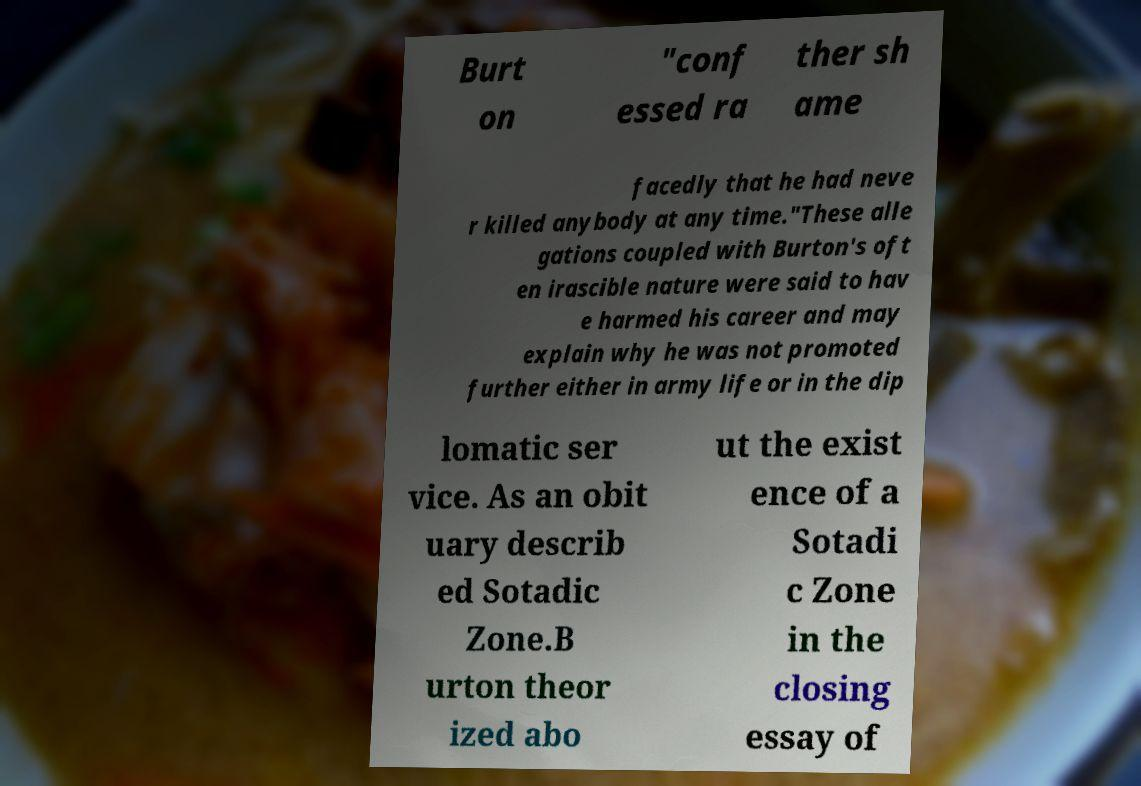There's text embedded in this image that I need extracted. Can you transcribe it verbatim? Burt on "conf essed ra ther sh ame facedly that he had neve r killed anybody at any time."These alle gations coupled with Burton's oft en irascible nature were said to hav e harmed his career and may explain why he was not promoted further either in army life or in the dip lomatic ser vice. As an obit uary describ ed Sotadic Zone.B urton theor ized abo ut the exist ence of a Sotadi c Zone in the closing essay of 